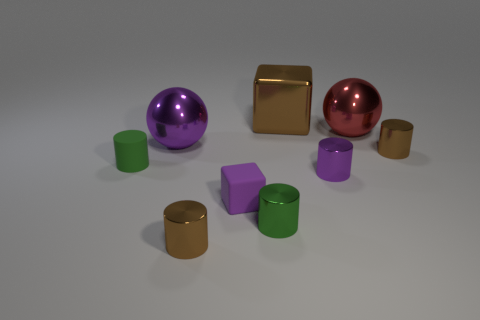What is the color of the other shiny thing that is the same shape as the large purple metallic thing?
Provide a short and direct response. Red. Is there anything else that is the same color as the shiny cube?
Keep it short and to the point. Yes. There is a purple object behind the shiny cylinder on the right side of the small purple thing behind the purple rubber block; what shape is it?
Ensure brevity in your answer.  Sphere. There is a brown thing that is to the right of the big red thing; is it the same size as the brown metal object behind the large red metallic object?
Keep it short and to the point. No. What number of large red spheres have the same material as the big block?
Your answer should be very brief. 1. Are there the same number of small metallic objects and brown objects?
Provide a short and direct response. No. There is a big metal sphere behind the big sphere that is left of the red object; how many big red shiny balls are on the left side of it?
Give a very brief answer. 0. Does the tiny green rubber thing have the same shape as the small purple metal object?
Provide a short and direct response. Yes. Is there a tiny brown metal thing of the same shape as the purple rubber thing?
Offer a very short reply. No. There is a brown thing that is the same size as the red metal object; what is its shape?
Ensure brevity in your answer.  Cube. 